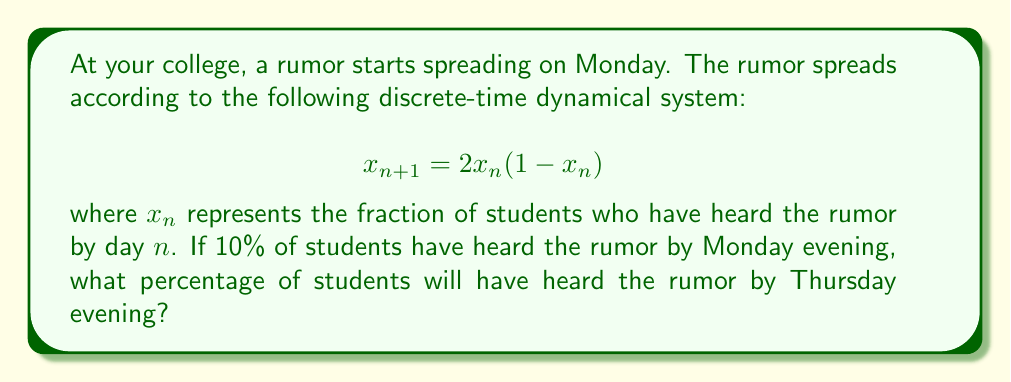Could you help me with this problem? Let's approach this step-by-step:

1) We're given that $x_0 = 0.1$ (10% of students on Monday evening).

2) We need to iterate the system three times to get to Thursday evening:

   For Tuesday (n = 1):
   $$x_1 = 2(0.1)(1-0.1) = 2(0.1)(0.9) = 0.18$$

   For Wednesday (n = 2):
   $$x_2 = 2(0.18)(1-0.18) = 2(0.18)(0.82) = 0.2952$$

   For Thursday (n = 3):
   $$x_3 = 2(0.2952)(1-0.2952) = 2(0.2952)(0.7048) \approx 0.4161$$

3) Converting to a percentage:
   0.4161 * 100% ≈ 41.61%

Therefore, by Thursday evening, approximately 41.61% of students will have heard the rumor.
Answer: 41.61% 